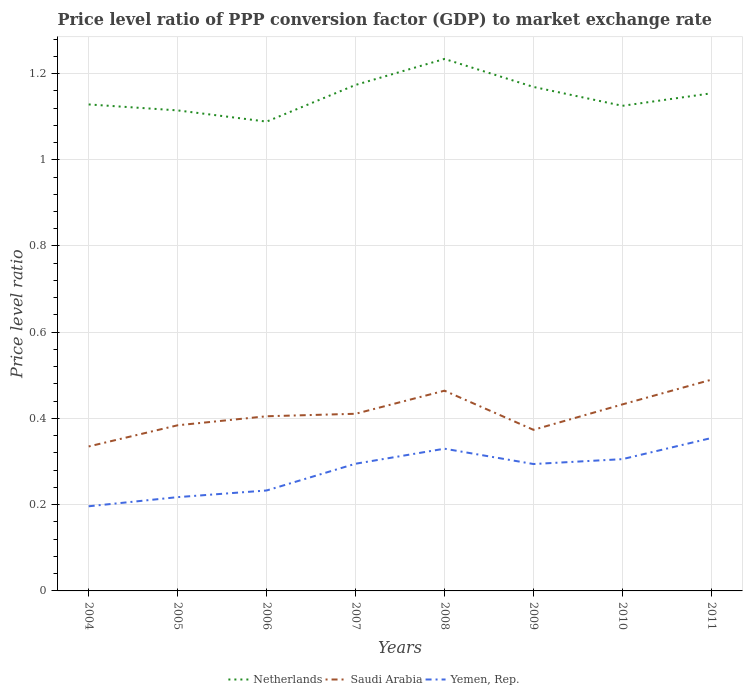Is the number of lines equal to the number of legend labels?
Provide a short and direct response. Yes. Across all years, what is the maximum price level ratio in Yemen, Rep.?
Provide a succinct answer. 0.2. In which year was the price level ratio in Netherlands maximum?
Your answer should be very brief. 2006. What is the total price level ratio in Yemen, Rep. in the graph?
Your answer should be compact. 0. What is the difference between the highest and the second highest price level ratio in Saudi Arabia?
Give a very brief answer. 0.15. What is the difference between the highest and the lowest price level ratio in Netherlands?
Your response must be concise. 4. What is the difference between two consecutive major ticks on the Y-axis?
Provide a short and direct response. 0.2. Does the graph contain grids?
Your answer should be compact. Yes. How are the legend labels stacked?
Keep it short and to the point. Horizontal. What is the title of the graph?
Provide a succinct answer. Price level ratio of PPP conversion factor (GDP) to market exchange rate. What is the label or title of the Y-axis?
Ensure brevity in your answer.  Price level ratio. What is the Price level ratio of Netherlands in 2004?
Offer a terse response. 1.13. What is the Price level ratio in Saudi Arabia in 2004?
Make the answer very short. 0.34. What is the Price level ratio of Yemen, Rep. in 2004?
Offer a very short reply. 0.2. What is the Price level ratio in Netherlands in 2005?
Your response must be concise. 1.11. What is the Price level ratio in Saudi Arabia in 2005?
Your answer should be compact. 0.38. What is the Price level ratio of Yemen, Rep. in 2005?
Keep it short and to the point. 0.22. What is the Price level ratio of Netherlands in 2006?
Give a very brief answer. 1.09. What is the Price level ratio of Saudi Arabia in 2006?
Keep it short and to the point. 0.41. What is the Price level ratio of Yemen, Rep. in 2006?
Provide a succinct answer. 0.23. What is the Price level ratio in Netherlands in 2007?
Your response must be concise. 1.17. What is the Price level ratio in Saudi Arabia in 2007?
Provide a short and direct response. 0.41. What is the Price level ratio in Yemen, Rep. in 2007?
Provide a short and direct response. 0.29. What is the Price level ratio in Netherlands in 2008?
Your answer should be very brief. 1.23. What is the Price level ratio in Saudi Arabia in 2008?
Offer a very short reply. 0.46. What is the Price level ratio of Yemen, Rep. in 2008?
Ensure brevity in your answer.  0.33. What is the Price level ratio of Netherlands in 2009?
Provide a succinct answer. 1.17. What is the Price level ratio of Saudi Arabia in 2009?
Offer a very short reply. 0.37. What is the Price level ratio of Yemen, Rep. in 2009?
Ensure brevity in your answer.  0.29. What is the Price level ratio in Netherlands in 2010?
Make the answer very short. 1.13. What is the Price level ratio in Saudi Arabia in 2010?
Make the answer very short. 0.43. What is the Price level ratio of Yemen, Rep. in 2010?
Ensure brevity in your answer.  0.31. What is the Price level ratio in Netherlands in 2011?
Provide a succinct answer. 1.15. What is the Price level ratio of Saudi Arabia in 2011?
Your response must be concise. 0.49. What is the Price level ratio in Yemen, Rep. in 2011?
Your answer should be compact. 0.35. Across all years, what is the maximum Price level ratio in Netherlands?
Offer a terse response. 1.23. Across all years, what is the maximum Price level ratio in Saudi Arabia?
Provide a short and direct response. 0.49. Across all years, what is the maximum Price level ratio in Yemen, Rep.?
Provide a succinct answer. 0.35. Across all years, what is the minimum Price level ratio of Netherlands?
Provide a succinct answer. 1.09. Across all years, what is the minimum Price level ratio of Saudi Arabia?
Offer a terse response. 0.34. Across all years, what is the minimum Price level ratio in Yemen, Rep.?
Give a very brief answer. 0.2. What is the total Price level ratio of Netherlands in the graph?
Offer a very short reply. 9.19. What is the total Price level ratio in Saudi Arabia in the graph?
Provide a short and direct response. 3.3. What is the total Price level ratio of Yemen, Rep. in the graph?
Give a very brief answer. 2.23. What is the difference between the Price level ratio in Netherlands in 2004 and that in 2005?
Your answer should be very brief. 0.01. What is the difference between the Price level ratio in Saudi Arabia in 2004 and that in 2005?
Make the answer very short. -0.05. What is the difference between the Price level ratio in Yemen, Rep. in 2004 and that in 2005?
Offer a very short reply. -0.02. What is the difference between the Price level ratio of Netherlands in 2004 and that in 2006?
Give a very brief answer. 0.04. What is the difference between the Price level ratio of Saudi Arabia in 2004 and that in 2006?
Give a very brief answer. -0.07. What is the difference between the Price level ratio in Yemen, Rep. in 2004 and that in 2006?
Your response must be concise. -0.04. What is the difference between the Price level ratio in Netherlands in 2004 and that in 2007?
Offer a terse response. -0.05. What is the difference between the Price level ratio in Saudi Arabia in 2004 and that in 2007?
Provide a succinct answer. -0.08. What is the difference between the Price level ratio in Yemen, Rep. in 2004 and that in 2007?
Your answer should be very brief. -0.1. What is the difference between the Price level ratio of Netherlands in 2004 and that in 2008?
Offer a terse response. -0.11. What is the difference between the Price level ratio of Saudi Arabia in 2004 and that in 2008?
Offer a very short reply. -0.13. What is the difference between the Price level ratio in Yemen, Rep. in 2004 and that in 2008?
Offer a terse response. -0.13. What is the difference between the Price level ratio in Netherlands in 2004 and that in 2009?
Keep it short and to the point. -0.04. What is the difference between the Price level ratio of Saudi Arabia in 2004 and that in 2009?
Give a very brief answer. -0.04. What is the difference between the Price level ratio in Yemen, Rep. in 2004 and that in 2009?
Offer a very short reply. -0.1. What is the difference between the Price level ratio of Netherlands in 2004 and that in 2010?
Offer a very short reply. 0. What is the difference between the Price level ratio in Saudi Arabia in 2004 and that in 2010?
Offer a terse response. -0.1. What is the difference between the Price level ratio of Yemen, Rep. in 2004 and that in 2010?
Provide a succinct answer. -0.11. What is the difference between the Price level ratio of Netherlands in 2004 and that in 2011?
Provide a succinct answer. -0.03. What is the difference between the Price level ratio of Saudi Arabia in 2004 and that in 2011?
Keep it short and to the point. -0.15. What is the difference between the Price level ratio of Yemen, Rep. in 2004 and that in 2011?
Your answer should be compact. -0.16. What is the difference between the Price level ratio in Netherlands in 2005 and that in 2006?
Your answer should be compact. 0.03. What is the difference between the Price level ratio of Saudi Arabia in 2005 and that in 2006?
Offer a very short reply. -0.02. What is the difference between the Price level ratio in Yemen, Rep. in 2005 and that in 2006?
Provide a succinct answer. -0.02. What is the difference between the Price level ratio of Netherlands in 2005 and that in 2007?
Provide a short and direct response. -0.06. What is the difference between the Price level ratio of Saudi Arabia in 2005 and that in 2007?
Your response must be concise. -0.03. What is the difference between the Price level ratio of Yemen, Rep. in 2005 and that in 2007?
Keep it short and to the point. -0.08. What is the difference between the Price level ratio of Netherlands in 2005 and that in 2008?
Keep it short and to the point. -0.12. What is the difference between the Price level ratio of Saudi Arabia in 2005 and that in 2008?
Offer a terse response. -0.08. What is the difference between the Price level ratio in Yemen, Rep. in 2005 and that in 2008?
Offer a terse response. -0.11. What is the difference between the Price level ratio of Netherlands in 2005 and that in 2009?
Keep it short and to the point. -0.05. What is the difference between the Price level ratio of Saudi Arabia in 2005 and that in 2009?
Provide a succinct answer. 0.01. What is the difference between the Price level ratio of Yemen, Rep. in 2005 and that in 2009?
Offer a very short reply. -0.08. What is the difference between the Price level ratio of Netherlands in 2005 and that in 2010?
Keep it short and to the point. -0.01. What is the difference between the Price level ratio in Saudi Arabia in 2005 and that in 2010?
Ensure brevity in your answer.  -0.05. What is the difference between the Price level ratio of Yemen, Rep. in 2005 and that in 2010?
Provide a short and direct response. -0.09. What is the difference between the Price level ratio in Netherlands in 2005 and that in 2011?
Your answer should be compact. -0.04. What is the difference between the Price level ratio in Saudi Arabia in 2005 and that in 2011?
Ensure brevity in your answer.  -0.11. What is the difference between the Price level ratio of Yemen, Rep. in 2005 and that in 2011?
Make the answer very short. -0.14. What is the difference between the Price level ratio of Netherlands in 2006 and that in 2007?
Ensure brevity in your answer.  -0.09. What is the difference between the Price level ratio of Saudi Arabia in 2006 and that in 2007?
Give a very brief answer. -0.01. What is the difference between the Price level ratio of Yemen, Rep. in 2006 and that in 2007?
Ensure brevity in your answer.  -0.06. What is the difference between the Price level ratio of Netherlands in 2006 and that in 2008?
Offer a terse response. -0.15. What is the difference between the Price level ratio in Saudi Arabia in 2006 and that in 2008?
Offer a very short reply. -0.06. What is the difference between the Price level ratio in Yemen, Rep. in 2006 and that in 2008?
Provide a short and direct response. -0.1. What is the difference between the Price level ratio of Netherlands in 2006 and that in 2009?
Offer a very short reply. -0.08. What is the difference between the Price level ratio in Saudi Arabia in 2006 and that in 2009?
Provide a succinct answer. 0.03. What is the difference between the Price level ratio in Yemen, Rep. in 2006 and that in 2009?
Your answer should be compact. -0.06. What is the difference between the Price level ratio in Netherlands in 2006 and that in 2010?
Ensure brevity in your answer.  -0.04. What is the difference between the Price level ratio in Saudi Arabia in 2006 and that in 2010?
Provide a succinct answer. -0.03. What is the difference between the Price level ratio in Yemen, Rep. in 2006 and that in 2010?
Make the answer very short. -0.07. What is the difference between the Price level ratio of Netherlands in 2006 and that in 2011?
Provide a short and direct response. -0.07. What is the difference between the Price level ratio of Saudi Arabia in 2006 and that in 2011?
Keep it short and to the point. -0.08. What is the difference between the Price level ratio of Yemen, Rep. in 2006 and that in 2011?
Your answer should be compact. -0.12. What is the difference between the Price level ratio of Netherlands in 2007 and that in 2008?
Provide a short and direct response. -0.06. What is the difference between the Price level ratio in Saudi Arabia in 2007 and that in 2008?
Offer a very short reply. -0.05. What is the difference between the Price level ratio of Yemen, Rep. in 2007 and that in 2008?
Provide a succinct answer. -0.03. What is the difference between the Price level ratio of Netherlands in 2007 and that in 2009?
Provide a succinct answer. 0. What is the difference between the Price level ratio in Saudi Arabia in 2007 and that in 2009?
Your answer should be compact. 0.04. What is the difference between the Price level ratio in Yemen, Rep. in 2007 and that in 2009?
Your answer should be compact. 0. What is the difference between the Price level ratio of Netherlands in 2007 and that in 2010?
Offer a terse response. 0.05. What is the difference between the Price level ratio in Saudi Arabia in 2007 and that in 2010?
Provide a succinct answer. -0.02. What is the difference between the Price level ratio of Yemen, Rep. in 2007 and that in 2010?
Your response must be concise. -0.01. What is the difference between the Price level ratio in Netherlands in 2007 and that in 2011?
Give a very brief answer. 0.02. What is the difference between the Price level ratio of Saudi Arabia in 2007 and that in 2011?
Your answer should be compact. -0.08. What is the difference between the Price level ratio of Yemen, Rep. in 2007 and that in 2011?
Provide a short and direct response. -0.06. What is the difference between the Price level ratio of Netherlands in 2008 and that in 2009?
Provide a succinct answer. 0.06. What is the difference between the Price level ratio of Saudi Arabia in 2008 and that in 2009?
Make the answer very short. 0.09. What is the difference between the Price level ratio in Yemen, Rep. in 2008 and that in 2009?
Provide a succinct answer. 0.04. What is the difference between the Price level ratio in Netherlands in 2008 and that in 2010?
Ensure brevity in your answer.  0.11. What is the difference between the Price level ratio in Saudi Arabia in 2008 and that in 2010?
Provide a succinct answer. 0.03. What is the difference between the Price level ratio of Yemen, Rep. in 2008 and that in 2010?
Provide a succinct answer. 0.02. What is the difference between the Price level ratio in Netherlands in 2008 and that in 2011?
Give a very brief answer. 0.08. What is the difference between the Price level ratio of Saudi Arabia in 2008 and that in 2011?
Provide a succinct answer. -0.03. What is the difference between the Price level ratio of Yemen, Rep. in 2008 and that in 2011?
Your answer should be very brief. -0.02. What is the difference between the Price level ratio in Netherlands in 2009 and that in 2010?
Provide a short and direct response. 0.04. What is the difference between the Price level ratio in Saudi Arabia in 2009 and that in 2010?
Offer a very short reply. -0.06. What is the difference between the Price level ratio in Yemen, Rep. in 2009 and that in 2010?
Offer a terse response. -0.01. What is the difference between the Price level ratio of Netherlands in 2009 and that in 2011?
Provide a succinct answer. 0.01. What is the difference between the Price level ratio of Saudi Arabia in 2009 and that in 2011?
Offer a terse response. -0.12. What is the difference between the Price level ratio in Yemen, Rep. in 2009 and that in 2011?
Keep it short and to the point. -0.06. What is the difference between the Price level ratio of Netherlands in 2010 and that in 2011?
Your response must be concise. -0.03. What is the difference between the Price level ratio of Saudi Arabia in 2010 and that in 2011?
Your answer should be compact. -0.06. What is the difference between the Price level ratio of Yemen, Rep. in 2010 and that in 2011?
Ensure brevity in your answer.  -0.05. What is the difference between the Price level ratio in Netherlands in 2004 and the Price level ratio in Saudi Arabia in 2005?
Provide a short and direct response. 0.74. What is the difference between the Price level ratio in Netherlands in 2004 and the Price level ratio in Yemen, Rep. in 2005?
Provide a short and direct response. 0.91. What is the difference between the Price level ratio in Saudi Arabia in 2004 and the Price level ratio in Yemen, Rep. in 2005?
Provide a succinct answer. 0.12. What is the difference between the Price level ratio in Netherlands in 2004 and the Price level ratio in Saudi Arabia in 2006?
Make the answer very short. 0.72. What is the difference between the Price level ratio of Netherlands in 2004 and the Price level ratio of Yemen, Rep. in 2006?
Provide a short and direct response. 0.9. What is the difference between the Price level ratio in Saudi Arabia in 2004 and the Price level ratio in Yemen, Rep. in 2006?
Offer a very short reply. 0.1. What is the difference between the Price level ratio in Netherlands in 2004 and the Price level ratio in Saudi Arabia in 2007?
Ensure brevity in your answer.  0.72. What is the difference between the Price level ratio of Saudi Arabia in 2004 and the Price level ratio of Yemen, Rep. in 2007?
Your response must be concise. 0.04. What is the difference between the Price level ratio of Netherlands in 2004 and the Price level ratio of Saudi Arabia in 2008?
Provide a short and direct response. 0.66. What is the difference between the Price level ratio of Netherlands in 2004 and the Price level ratio of Yemen, Rep. in 2008?
Offer a very short reply. 0.8. What is the difference between the Price level ratio in Saudi Arabia in 2004 and the Price level ratio in Yemen, Rep. in 2008?
Give a very brief answer. 0.01. What is the difference between the Price level ratio of Netherlands in 2004 and the Price level ratio of Saudi Arabia in 2009?
Ensure brevity in your answer.  0.75. What is the difference between the Price level ratio of Netherlands in 2004 and the Price level ratio of Yemen, Rep. in 2009?
Offer a terse response. 0.83. What is the difference between the Price level ratio of Saudi Arabia in 2004 and the Price level ratio of Yemen, Rep. in 2009?
Keep it short and to the point. 0.04. What is the difference between the Price level ratio of Netherlands in 2004 and the Price level ratio of Saudi Arabia in 2010?
Offer a terse response. 0.7. What is the difference between the Price level ratio in Netherlands in 2004 and the Price level ratio in Yemen, Rep. in 2010?
Your response must be concise. 0.82. What is the difference between the Price level ratio in Saudi Arabia in 2004 and the Price level ratio in Yemen, Rep. in 2010?
Offer a very short reply. 0.03. What is the difference between the Price level ratio of Netherlands in 2004 and the Price level ratio of Saudi Arabia in 2011?
Provide a succinct answer. 0.64. What is the difference between the Price level ratio in Netherlands in 2004 and the Price level ratio in Yemen, Rep. in 2011?
Give a very brief answer. 0.77. What is the difference between the Price level ratio in Saudi Arabia in 2004 and the Price level ratio in Yemen, Rep. in 2011?
Ensure brevity in your answer.  -0.02. What is the difference between the Price level ratio of Netherlands in 2005 and the Price level ratio of Saudi Arabia in 2006?
Keep it short and to the point. 0.71. What is the difference between the Price level ratio in Netherlands in 2005 and the Price level ratio in Yemen, Rep. in 2006?
Make the answer very short. 0.88. What is the difference between the Price level ratio of Saudi Arabia in 2005 and the Price level ratio of Yemen, Rep. in 2006?
Provide a succinct answer. 0.15. What is the difference between the Price level ratio of Netherlands in 2005 and the Price level ratio of Saudi Arabia in 2007?
Ensure brevity in your answer.  0.7. What is the difference between the Price level ratio of Netherlands in 2005 and the Price level ratio of Yemen, Rep. in 2007?
Your response must be concise. 0.82. What is the difference between the Price level ratio in Saudi Arabia in 2005 and the Price level ratio in Yemen, Rep. in 2007?
Your response must be concise. 0.09. What is the difference between the Price level ratio in Netherlands in 2005 and the Price level ratio in Saudi Arabia in 2008?
Your answer should be very brief. 0.65. What is the difference between the Price level ratio in Netherlands in 2005 and the Price level ratio in Yemen, Rep. in 2008?
Your answer should be compact. 0.78. What is the difference between the Price level ratio of Saudi Arabia in 2005 and the Price level ratio of Yemen, Rep. in 2008?
Make the answer very short. 0.05. What is the difference between the Price level ratio in Netherlands in 2005 and the Price level ratio in Saudi Arabia in 2009?
Your response must be concise. 0.74. What is the difference between the Price level ratio in Netherlands in 2005 and the Price level ratio in Yemen, Rep. in 2009?
Provide a succinct answer. 0.82. What is the difference between the Price level ratio in Saudi Arabia in 2005 and the Price level ratio in Yemen, Rep. in 2009?
Offer a terse response. 0.09. What is the difference between the Price level ratio in Netherlands in 2005 and the Price level ratio in Saudi Arabia in 2010?
Ensure brevity in your answer.  0.68. What is the difference between the Price level ratio in Netherlands in 2005 and the Price level ratio in Yemen, Rep. in 2010?
Make the answer very short. 0.81. What is the difference between the Price level ratio in Saudi Arabia in 2005 and the Price level ratio in Yemen, Rep. in 2010?
Give a very brief answer. 0.08. What is the difference between the Price level ratio in Netherlands in 2005 and the Price level ratio in Saudi Arabia in 2011?
Keep it short and to the point. 0.62. What is the difference between the Price level ratio in Netherlands in 2005 and the Price level ratio in Yemen, Rep. in 2011?
Provide a short and direct response. 0.76. What is the difference between the Price level ratio in Saudi Arabia in 2005 and the Price level ratio in Yemen, Rep. in 2011?
Your answer should be very brief. 0.03. What is the difference between the Price level ratio in Netherlands in 2006 and the Price level ratio in Saudi Arabia in 2007?
Keep it short and to the point. 0.68. What is the difference between the Price level ratio in Netherlands in 2006 and the Price level ratio in Yemen, Rep. in 2007?
Keep it short and to the point. 0.79. What is the difference between the Price level ratio in Saudi Arabia in 2006 and the Price level ratio in Yemen, Rep. in 2007?
Your answer should be compact. 0.11. What is the difference between the Price level ratio in Netherlands in 2006 and the Price level ratio in Saudi Arabia in 2008?
Your answer should be compact. 0.62. What is the difference between the Price level ratio in Netherlands in 2006 and the Price level ratio in Yemen, Rep. in 2008?
Give a very brief answer. 0.76. What is the difference between the Price level ratio in Saudi Arabia in 2006 and the Price level ratio in Yemen, Rep. in 2008?
Offer a very short reply. 0.08. What is the difference between the Price level ratio in Netherlands in 2006 and the Price level ratio in Saudi Arabia in 2009?
Provide a succinct answer. 0.71. What is the difference between the Price level ratio in Netherlands in 2006 and the Price level ratio in Yemen, Rep. in 2009?
Provide a short and direct response. 0.79. What is the difference between the Price level ratio in Saudi Arabia in 2006 and the Price level ratio in Yemen, Rep. in 2009?
Make the answer very short. 0.11. What is the difference between the Price level ratio in Netherlands in 2006 and the Price level ratio in Saudi Arabia in 2010?
Make the answer very short. 0.66. What is the difference between the Price level ratio in Netherlands in 2006 and the Price level ratio in Yemen, Rep. in 2010?
Provide a succinct answer. 0.78. What is the difference between the Price level ratio of Saudi Arabia in 2006 and the Price level ratio of Yemen, Rep. in 2010?
Ensure brevity in your answer.  0.1. What is the difference between the Price level ratio in Netherlands in 2006 and the Price level ratio in Saudi Arabia in 2011?
Ensure brevity in your answer.  0.6. What is the difference between the Price level ratio in Netherlands in 2006 and the Price level ratio in Yemen, Rep. in 2011?
Offer a terse response. 0.73. What is the difference between the Price level ratio of Saudi Arabia in 2006 and the Price level ratio of Yemen, Rep. in 2011?
Your response must be concise. 0.05. What is the difference between the Price level ratio of Netherlands in 2007 and the Price level ratio of Saudi Arabia in 2008?
Keep it short and to the point. 0.71. What is the difference between the Price level ratio of Netherlands in 2007 and the Price level ratio of Yemen, Rep. in 2008?
Your response must be concise. 0.84. What is the difference between the Price level ratio in Saudi Arabia in 2007 and the Price level ratio in Yemen, Rep. in 2008?
Offer a very short reply. 0.08. What is the difference between the Price level ratio of Netherlands in 2007 and the Price level ratio of Saudi Arabia in 2009?
Offer a terse response. 0.8. What is the difference between the Price level ratio of Netherlands in 2007 and the Price level ratio of Yemen, Rep. in 2009?
Give a very brief answer. 0.88. What is the difference between the Price level ratio in Saudi Arabia in 2007 and the Price level ratio in Yemen, Rep. in 2009?
Keep it short and to the point. 0.12. What is the difference between the Price level ratio in Netherlands in 2007 and the Price level ratio in Saudi Arabia in 2010?
Make the answer very short. 0.74. What is the difference between the Price level ratio in Netherlands in 2007 and the Price level ratio in Yemen, Rep. in 2010?
Provide a short and direct response. 0.87. What is the difference between the Price level ratio of Saudi Arabia in 2007 and the Price level ratio of Yemen, Rep. in 2010?
Your response must be concise. 0.11. What is the difference between the Price level ratio in Netherlands in 2007 and the Price level ratio in Saudi Arabia in 2011?
Your answer should be very brief. 0.68. What is the difference between the Price level ratio of Netherlands in 2007 and the Price level ratio of Yemen, Rep. in 2011?
Offer a terse response. 0.82. What is the difference between the Price level ratio in Saudi Arabia in 2007 and the Price level ratio in Yemen, Rep. in 2011?
Offer a very short reply. 0.06. What is the difference between the Price level ratio in Netherlands in 2008 and the Price level ratio in Saudi Arabia in 2009?
Ensure brevity in your answer.  0.86. What is the difference between the Price level ratio of Netherlands in 2008 and the Price level ratio of Yemen, Rep. in 2009?
Your answer should be very brief. 0.94. What is the difference between the Price level ratio of Saudi Arabia in 2008 and the Price level ratio of Yemen, Rep. in 2009?
Offer a very short reply. 0.17. What is the difference between the Price level ratio in Netherlands in 2008 and the Price level ratio in Saudi Arabia in 2010?
Your answer should be very brief. 0.8. What is the difference between the Price level ratio in Netherlands in 2008 and the Price level ratio in Yemen, Rep. in 2010?
Keep it short and to the point. 0.93. What is the difference between the Price level ratio in Saudi Arabia in 2008 and the Price level ratio in Yemen, Rep. in 2010?
Your answer should be very brief. 0.16. What is the difference between the Price level ratio of Netherlands in 2008 and the Price level ratio of Saudi Arabia in 2011?
Make the answer very short. 0.74. What is the difference between the Price level ratio of Netherlands in 2008 and the Price level ratio of Yemen, Rep. in 2011?
Give a very brief answer. 0.88. What is the difference between the Price level ratio of Saudi Arabia in 2008 and the Price level ratio of Yemen, Rep. in 2011?
Provide a short and direct response. 0.11. What is the difference between the Price level ratio of Netherlands in 2009 and the Price level ratio of Saudi Arabia in 2010?
Provide a succinct answer. 0.74. What is the difference between the Price level ratio of Netherlands in 2009 and the Price level ratio of Yemen, Rep. in 2010?
Give a very brief answer. 0.86. What is the difference between the Price level ratio of Saudi Arabia in 2009 and the Price level ratio of Yemen, Rep. in 2010?
Keep it short and to the point. 0.07. What is the difference between the Price level ratio of Netherlands in 2009 and the Price level ratio of Saudi Arabia in 2011?
Your response must be concise. 0.68. What is the difference between the Price level ratio of Netherlands in 2009 and the Price level ratio of Yemen, Rep. in 2011?
Offer a terse response. 0.81. What is the difference between the Price level ratio in Saudi Arabia in 2009 and the Price level ratio in Yemen, Rep. in 2011?
Ensure brevity in your answer.  0.02. What is the difference between the Price level ratio of Netherlands in 2010 and the Price level ratio of Saudi Arabia in 2011?
Provide a short and direct response. 0.64. What is the difference between the Price level ratio in Netherlands in 2010 and the Price level ratio in Yemen, Rep. in 2011?
Your answer should be very brief. 0.77. What is the difference between the Price level ratio in Saudi Arabia in 2010 and the Price level ratio in Yemen, Rep. in 2011?
Make the answer very short. 0.08. What is the average Price level ratio of Netherlands per year?
Provide a succinct answer. 1.15. What is the average Price level ratio of Saudi Arabia per year?
Offer a very short reply. 0.41. What is the average Price level ratio of Yemen, Rep. per year?
Provide a succinct answer. 0.28. In the year 2004, what is the difference between the Price level ratio of Netherlands and Price level ratio of Saudi Arabia?
Ensure brevity in your answer.  0.79. In the year 2004, what is the difference between the Price level ratio of Netherlands and Price level ratio of Yemen, Rep.?
Make the answer very short. 0.93. In the year 2004, what is the difference between the Price level ratio in Saudi Arabia and Price level ratio in Yemen, Rep.?
Provide a short and direct response. 0.14. In the year 2005, what is the difference between the Price level ratio of Netherlands and Price level ratio of Saudi Arabia?
Offer a terse response. 0.73. In the year 2005, what is the difference between the Price level ratio in Netherlands and Price level ratio in Yemen, Rep.?
Provide a succinct answer. 0.9. In the year 2005, what is the difference between the Price level ratio in Saudi Arabia and Price level ratio in Yemen, Rep.?
Offer a very short reply. 0.17. In the year 2006, what is the difference between the Price level ratio in Netherlands and Price level ratio in Saudi Arabia?
Ensure brevity in your answer.  0.68. In the year 2006, what is the difference between the Price level ratio in Netherlands and Price level ratio in Yemen, Rep.?
Give a very brief answer. 0.86. In the year 2006, what is the difference between the Price level ratio of Saudi Arabia and Price level ratio of Yemen, Rep.?
Provide a short and direct response. 0.17. In the year 2007, what is the difference between the Price level ratio of Netherlands and Price level ratio of Saudi Arabia?
Your response must be concise. 0.76. In the year 2007, what is the difference between the Price level ratio of Netherlands and Price level ratio of Yemen, Rep.?
Offer a very short reply. 0.88. In the year 2007, what is the difference between the Price level ratio in Saudi Arabia and Price level ratio in Yemen, Rep.?
Ensure brevity in your answer.  0.12. In the year 2008, what is the difference between the Price level ratio of Netherlands and Price level ratio of Saudi Arabia?
Ensure brevity in your answer.  0.77. In the year 2008, what is the difference between the Price level ratio of Netherlands and Price level ratio of Yemen, Rep.?
Offer a terse response. 0.9. In the year 2008, what is the difference between the Price level ratio in Saudi Arabia and Price level ratio in Yemen, Rep.?
Your answer should be compact. 0.13. In the year 2009, what is the difference between the Price level ratio in Netherlands and Price level ratio in Saudi Arabia?
Your response must be concise. 0.8. In the year 2009, what is the difference between the Price level ratio in Netherlands and Price level ratio in Yemen, Rep.?
Give a very brief answer. 0.87. In the year 2009, what is the difference between the Price level ratio of Saudi Arabia and Price level ratio of Yemen, Rep.?
Make the answer very short. 0.08. In the year 2010, what is the difference between the Price level ratio of Netherlands and Price level ratio of Saudi Arabia?
Ensure brevity in your answer.  0.69. In the year 2010, what is the difference between the Price level ratio of Netherlands and Price level ratio of Yemen, Rep.?
Your answer should be very brief. 0.82. In the year 2010, what is the difference between the Price level ratio in Saudi Arabia and Price level ratio in Yemen, Rep.?
Provide a succinct answer. 0.13. In the year 2011, what is the difference between the Price level ratio of Netherlands and Price level ratio of Saudi Arabia?
Provide a succinct answer. 0.66. In the year 2011, what is the difference between the Price level ratio of Netherlands and Price level ratio of Yemen, Rep.?
Keep it short and to the point. 0.8. In the year 2011, what is the difference between the Price level ratio of Saudi Arabia and Price level ratio of Yemen, Rep.?
Your answer should be compact. 0.14. What is the ratio of the Price level ratio in Netherlands in 2004 to that in 2005?
Keep it short and to the point. 1.01. What is the ratio of the Price level ratio of Saudi Arabia in 2004 to that in 2005?
Offer a very short reply. 0.87. What is the ratio of the Price level ratio in Yemen, Rep. in 2004 to that in 2005?
Provide a succinct answer. 0.9. What is the ratio of the Price level ratio in Netherlands in 2004 to that in 2006?
Make the answer very short. 1.04. What is the ratio of the Price level ratio in Saudi Arabia in 2004 to that in 2006?
Provide a succinct answer. 0.83. What is the ratio of the Price level ratio in Yemen, Rep. in 2004 to that in 2006?
Provide a short and direct response. 0.84. What is the ratio of the Price level ratio in Netherlands in 2004 to that in 2007?
Your answer should be very brief. 0.96. What is the ratio of the Price level ratio of Saudi Arabia in 2004 to that in 2007?
Your response must be concise. 0.82. What is the ratio of the Price level ratio of Yemen, Rep. in 2004 to that in 2007?
Your answer should be very brief. 0.67. What is the ratio of the Price level ratio of Netherlands in 2004 to that in 2008?
Ensure brevity in your answer.  0.91. What is the ratio of the Price level ratio of Saudi Arabia in 2004 to that in 2008?
Give a very brief answer. 0.72. What is the ratio of the Price level ratio of Yemen, Rep. in 2004 to that in 2008?
Provide a short and direct response. 0.6. What is the ratio of the Price level ratio of Netherlands in 2004 to that in 2009?
Make the answer very short. 0.97. What is the ratio of the Price level ratio of Saudi Arabia in 2004 to that in 2009?
Make the answer very short. 0.9. What is the ratio of the Price level ratio of Yemen, Rep. in 2004 to that in 2009?
Offer a terse response. 0.67. What is the ratio of the Price level ratio of Saudi Arabia in 2004 to that in 2010?
Your answer should be compact. 0.77. What is the ratio of the Price level ratio of Yemen, Rep. in 2004 to that in 2010?
Your answer should be compact. 0.64. What is the ratio of the Price level ratio of Netherlands in 2004 to that in 2011?
Keep it short and to the point. 0.98. What is the ratio of the Price level ratio in Saudi Arabia in 2004 to that in 2011?
Offer a very short reply. 0.68. What is the ratio of the Price level ratio in Yemen, Rep. in 2004 to that in 2011?
Your answer should be compact. 0.55. What is the ratio of the Price level ratio in Netherlands in 2005 to that in 2006?
Keep it short and to the point. 1.02. What is the ratio of the Price level ratio of Saudi Arabia in 2005 to that in 2006?
Your answer should be very brief. 0.95. What is the ratio of the Price level ratio of Yemen, Rep. in 2005 to that in 2006?
Your answer should be compact. 0.93. What is the ratio of the Price level ratio in Netherlands in 2005 to that in 2007?
Keep it short and to the point. 0.95. What is the ratio of the Price level ratio in Saudi Arabia in 2005 to that in 2007?
Offer a terse response. 0.94. What is the ratio of the Price level ratio of Yemen, Rep. in 2005 to that in 2007?
Your answer should be compact. 0.74. What is the ratio of the Price level ratio of Netherlands in 2005 to that in 2008?
Your answer should be very brief. 0.9. What is the ratio of the Price level ratio in Saudi Arabia in 2005 to that in 2008?
Offer a very short reply. 0.83. What is the ratio of the Price level ratio in Yemen, Rep. in 2005 to that in 2008?
Your response must be concise. 0.66. What is the ratio of the Price level ratio of Netherlands in 2005 to that in 2009?
Provide a short and direct response. 0.95. What is the ratio of the Price level ratio of Saudi Arabia in 2005 to that in 2009?
Give a very brief answer. 1.03. What is the ratio of the Price level ratio of Yemen, Rep. in 2005 to that in 2009?
Give a very brief answer. 0.74. What is the ratio of the Price level ratio in Netherlands in 2005 to that in 2010?
Ensure brevity in your answer.  0.99. What is the ratio of the Price level ratio of Saudi Arabia in 2005 to that in 2010?
Your response must be concise. 0.89. What is the ratio of the Price level ratio of Yemen, Rep. in 2005 to that in 2010?
Your response must be concise. 0.71. What is the ratio of the Price level ratio in Netherlands in 2005 to that in 2011?
Your answer should be compact. 0.97. What is the ratio of the Price level ratio of Saudi Arabia in 2005 to that in 2011?
Keep it short and to the point. 0.78. What is the ratio of the Price level ratio in Yemen, Rep. in 2005 to that in 2011?
Offer a terse response. 0.61. What is the ratio of the Price level ratio of Netherlands in 2006 to that in 2007?
Give a very brief answer. 0.93. What is the ratio of the Price level ratio in Saudi Arabia in 2006 to that in 2007?
Your response must be concise. 0.99. What is the ratio of the Price level ratio in Yemen, Rep. in 2006 to that in 2007?
Make the answer very short. 0.79. What is the ratio of the Price level ratio of Netherlands in 2006 to that in 2008?
Offer a terse response. 0.88. What is the ratio of the Price level ratio in Saudi Arabia in 2006 to that in 2008?
Provide a succinct answer. 0.87. What is the ratio of the Price level ratio of Yemen, Rep. in 2006 to that in 2008?
Offer a terse response. 0.71. What is the ratio of the Price level ratio of Netherlands in 2006 to that in 2009?
Offer a very short reply. 0.93. What is the ratio of the Price level ratio in Saudi Arabia in 2006 to that in 2009?
Give a very brief answer. 1.08. What is the ratio of the Price level ratio in Yemen, Rep. in 2006 to that in 2009?
Your response must be concise. 0.79. What is the ratio of the Price level ratio of Netherlands in 2006 to that in 2010?
Provide a succinct answer. 0.97. What is the ratio of the Price level ratio in Saudi Arabia in 2006 to that in 2010?
Keep it short and to the point. 0.94. What is the ratio of the Price level ratio in Yemen, Rep. in 2006 to that in 2010?
Your answer should be very brief. 0.76. What is the ratio of the Price level ratio of Netherlands in 2006 to that in 2011?
Offer a terse response. 0.94. What is the ratio of the Price level ratio in Saudi Arabia in 2006 to that in 2011?
Provide a short and direct response. 0.83. What is the ratio of the Price level ratio of Yemen, Rep. in 2006 to that in 2011?
Give a very brief answer. 0.66. What is the ratio of the Price level ratio of Netherlands in 2007 to that in 2008?
Provide a succinct answer. 0.95. What is the ratio of the Price level ratio of Saudi Arabia in 2007 to that in 2008?
Make the answer very short. 0.88. What is the ratio of the Price level ratio in Yemen, Rep. in 2007 to that in 2008?
Your answer should be very brief. 0.89. What is the ratio of the Price level ratio in Saudi Arabia in 2007 to that in 2009?
Offer a very short reply. 1.1. What is the ratio of the Price level ratio of Yemen, Rep. in 2007 to that in 2009?
Offer a terse response. 1. What is the ratio of the Price level ratio of Netherlands in 2007 to that in 2010?
Provide a succinct answer. 1.04. What is the ratio of the Price level ratio of Saudi Arabia in 2007 to that in 2010?
Offer a terse response. 0.95. What is the ratio of the Price level ratio in Yemen, Rep. in 2007 to that in 2010?
Your answer should be very brief. 0.97. What is the ratio of the Price level ratio of Netherlands in 2007 to that in 2011?
Ensure brevity in your answer.  1.02. What is the ratio of the Price level ratio in Saudi Arabia in 2007 to that in 2011?
Your answer should be very brief. 0.84. What is the ratio of the Price level ratio in Yemen, Rep. in 2007 to that in 2011?
Give a very brief answer. 0.83. What is the ratio of the Price level ratio of Netherlands in 2008 to that in 2009?
Ensure brevity in your answer.  1.06. What is the ratio of the Price level ratio of Saudi Arabia in 2008 to that in 2009?
Provide a short and direct response. 1.24. What is the ratio of the Price level ratio of Yemen, Rep. in 2008 to that in 2009?
Give a very brief answer. 1.12. What is the ratio of the Price level ratio of Netherlands in 2008 to that in 2010?
Provide a succinct answer. 1.1. What is the ratio of the Price level ratio in Saudi Arabia in 2008 to that in 2010?
Your answer should be compact. 1.07. What is the ratio of the Price level ratio of Yemen, Rep. in 2008 to that in 2010?
Give a very brief answer. 1.08. What is the ratio of the Price level ratio in Netherlands in 2008 to that in 2011?
Your answer should be compact. 1.07. What is the ratio of the Price level ratio in Saudi Arabia in 2008 to that in 2011?
Ensure brevity in your answer.  0.95. What is the ratio of the Price level ratio of Yemen, Rep. in 2008 to that in 2011?
Keep it short and to the point. 0.93. What is the ratio of the Price level ratio in Netherlands in 2009 to that in 2010?
Your response must be concise. 1.04. What is the ratio of the Price level ratio of Saudi Arabia in 2009 to that in 2010?
Your answer should be compact. 0.86. What is the ratio of the Price level ratio of Netherlands in 2009 to that in 2011?
Your response must be concise. 1.01. What is the ratio of the Price level ratio in Saudi Arabia in 2009 to that in 2011?
Provide a short and direct response. 0.76. What is the ratio of the Price level ratio in Yemen, Rep. in 2009 to that in 2011?
Keep it short and to the point. 0.83. What is the ratio of the Price level ratio of Netherlands in 2010 to that in 2011?
Provide a short and direct response. 0.97. What is the ratio of the Price level ratio in Saudi Arabia in 2010 to that in 2011?
Give a very brief answer. 0.88. What is the ratio of the Price level ratio of Yemen, Rep. in 2010 to that in 2011?
Your answer should be compact. 0.86. What is the difference between the highest and the second highest Price level ratio of Netherlands?
Your answer should be very brief. 0.06. What is the difference between the highest and the second highest Price level ratio of Saudi Arabia?
Ensure brevity in your answer.  0.03. What is the difference between the highest and the second highest Price level ratio in Yemen, Rep.?
Provide a succinct answer. 0.02. What is the difference between the highest and the lowest Price level ratio in Netherlands?
Provide a short and direct response. 0.15. What is the difference between the highest and the lowest Price level ratio in Saudi Arabia?
Offer a very short reply. 0.15. What is the difference between the highest and the lowest Price level ratio in Yemen, Rep.?
Provide a succinct answer. 0.16. 